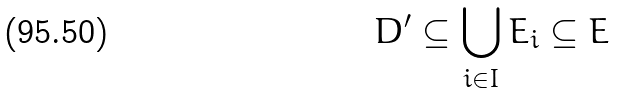Convert formula to latex. <formula><loc_0><loc_0><loc_500><loc_500>D ^ { \prime } \subseteq \bigcup _ { i \in I } E _ { i } \subseteq E</formula> 